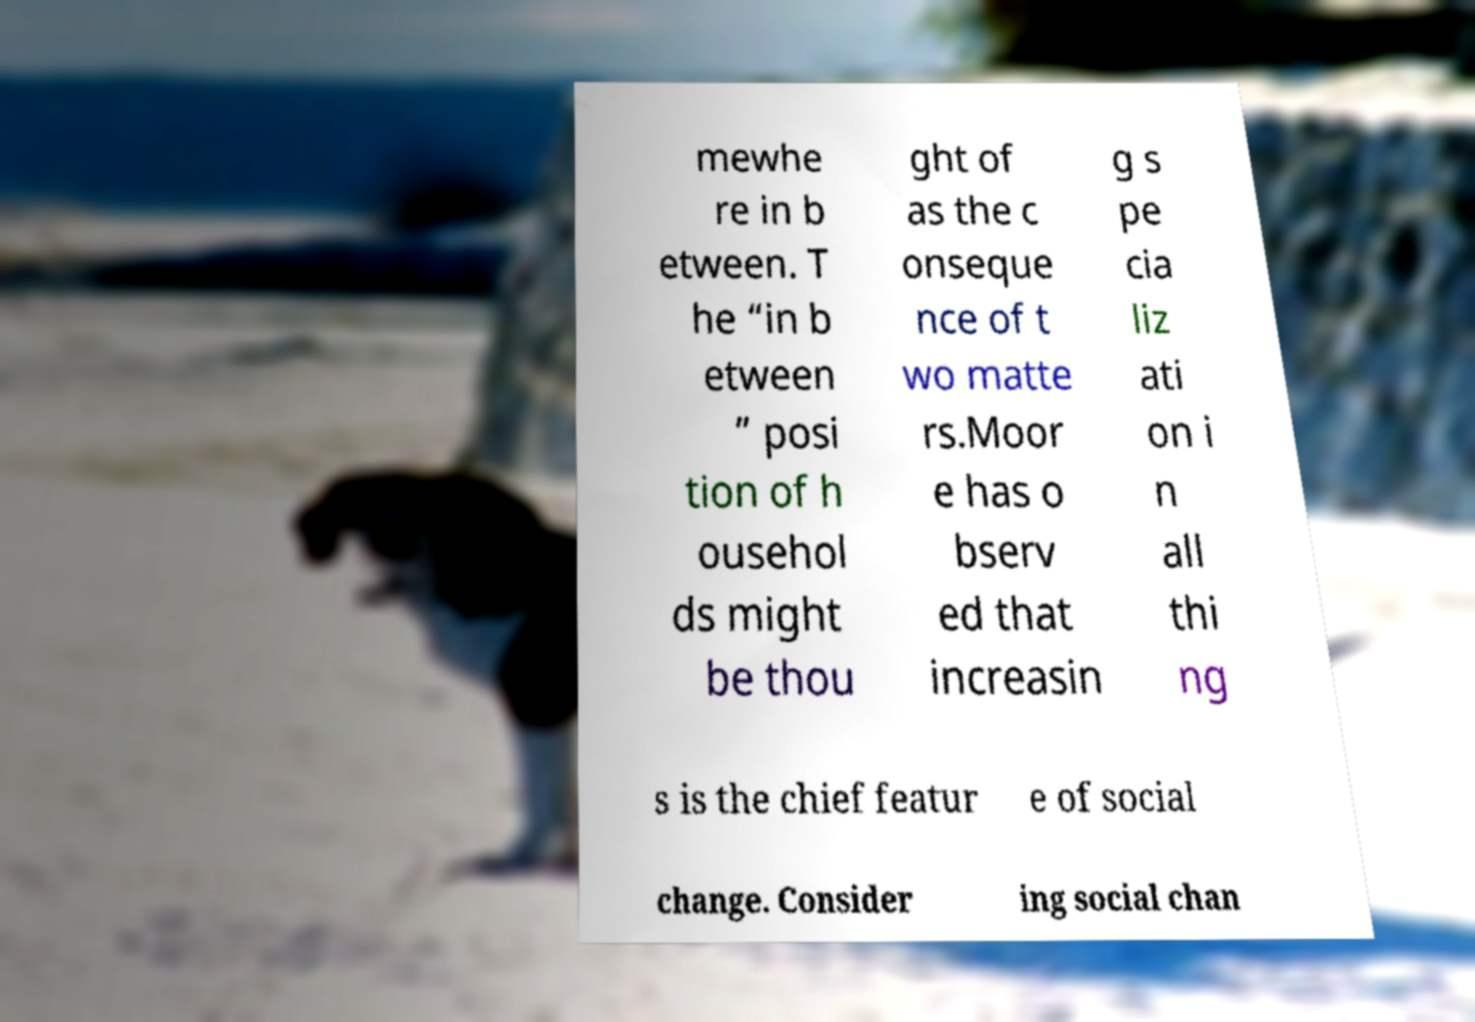There's text embedded in this image that I need extracted. Can you transcribe it verbatim? mewhe re in b etween. T he “in b etween ” posi tion of h ousehol ds might be thou ght of as the c onseque nce of t wo matte rs.Moor e has o bserv ed that increasin g s pe cia liz ati on i n all thi ng s is the chief featur e of social change. Consider ing social chan 